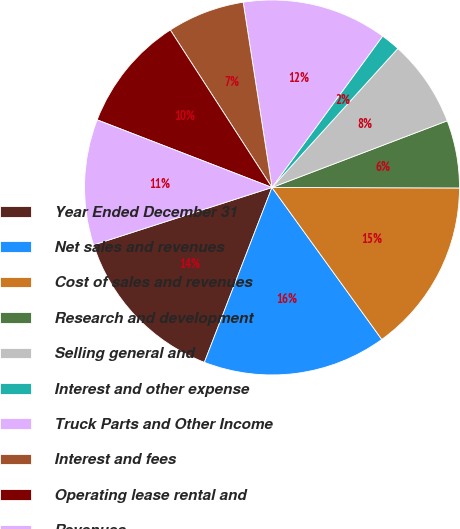Convert chart. <chart><loc_0><loc_0><loc_500><loc_500><pie_chart><fcel>Year Ended December 31<fcel>Net sales and revenues<fcel>Cost of sales and revenues<fcel>Research and development<fcel>Selling general and<fcel>Interest and other expense<fcel>Truck Parts and Other Income<fcel>Interest and fees<fcel>Operating lease rental and<fcel>Revenues<nl><fcel>14.17%<fcel>15.83%<fcel>15.0%<fcel>5.83%<fcel>7.5%<fcel>1.67%<fcel>12.5%<fcel>6.67%<fcel>10.0%<fcel>10.83%<nl></chart> 